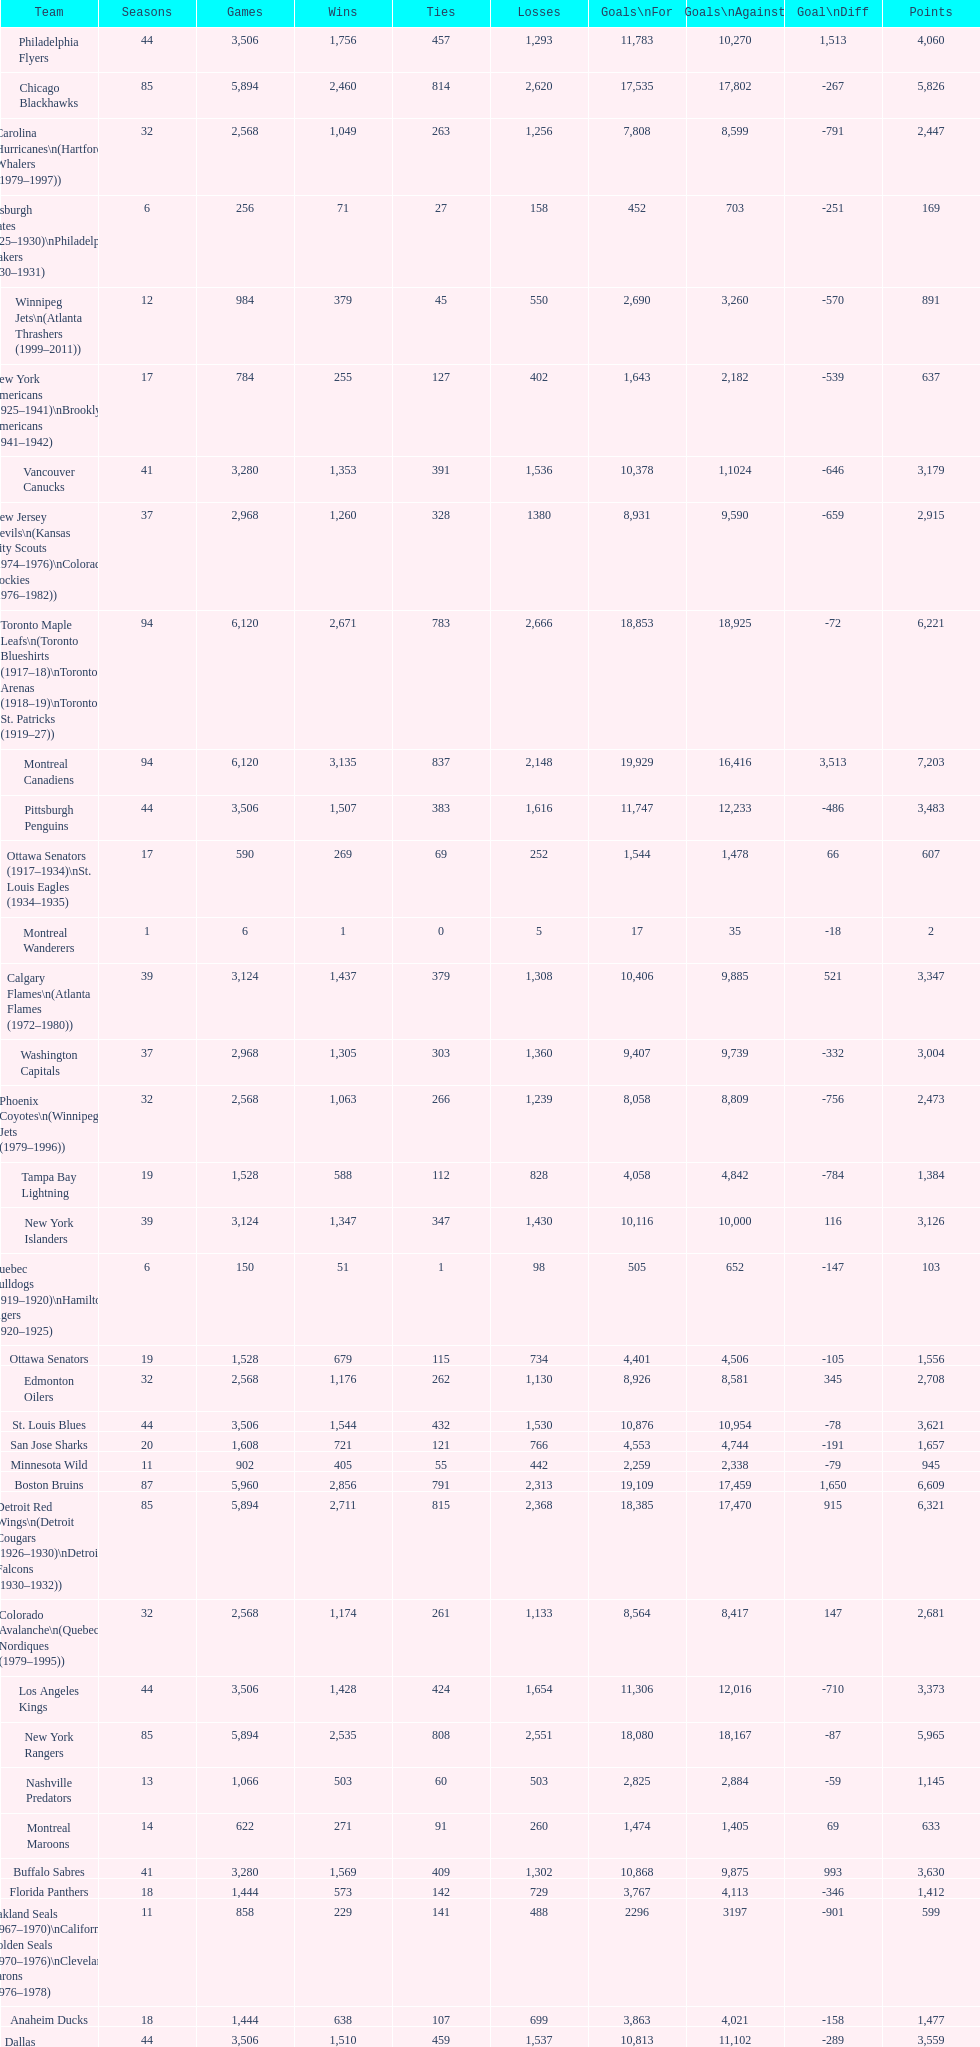Which team played the same amount of seasons as the canadiens? Toronto Maple Leafs. 